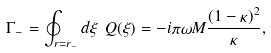<formula> <loc_0><loc_0><loc_500><loc_500>\Gamma _ { - } = \oint _ { r = r _ { - } } d \xi \ Q ( \xi ) = - i \pi \omega M \frac { ( 1 - \kappa ) ^ { 2 } } { \kappa } ,</formula> 